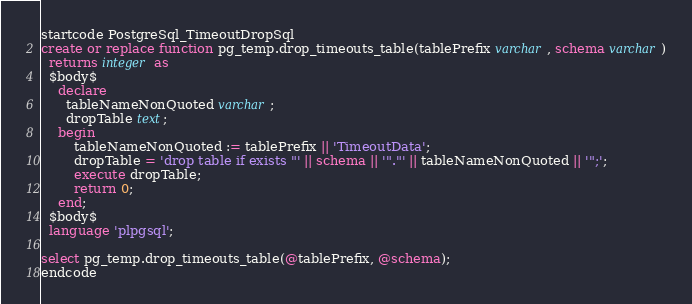<code> <loc_0><loc_0><loc_500><loc_500><_SQL_>startcode PostgreSql_TimeoutDropSql
create or replace function pg_temp.drop_timeouts_table(tablePrefix varchar, schema varchar)
  returns integer as
  $body$
    declare
      tableNameNonQuoted varchar;
      dropTable text;
    begin
        tableNameNonQuoted := tablePrefix || 'TimeoutData';
        dropTable = 'drop table if exists "' || schema || '"."' || tableNameNonQuoted || '";';
        execute dropTable;
        return 0;
    end;
  $body$
  language 'plpgsql';

select pg_temp.drop_timeouts_table(@tablePrefix, @schema);
endcode
</code> 